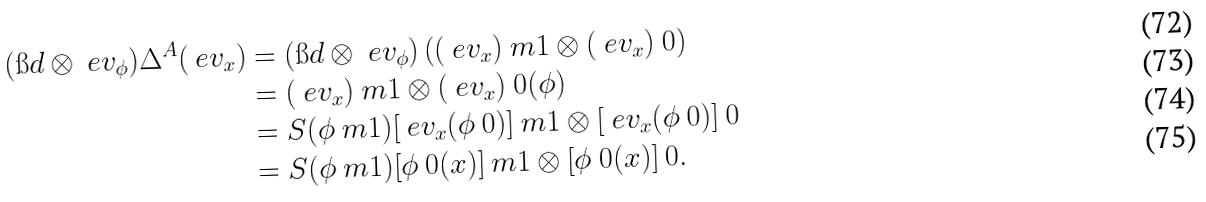<formula> <loc_0><loc_0><loc_500><loc_500>( \i d \otimes \ e v _ { \phi } ) \Delta ^ { A } ( \ e v _ { x } ) & = ( \i d \otimes \ e v _ { \phi } ) \left ( ( \ e v _ { x } ) \ m 1 \otimes ( \ e v _ { x } ) \ 0 \right ) \\ & = ( \ e v _ { x } ) \ m 1 \otimes ( \ e v _ { x } ) \ 0 ( \phi ) \\ & = S ( \phi \ m 1 ) [ \ e v _ { x } ( \phi \ 0 ) ] \ m 1 \otimes [ \ e v _ { x } ( \phi \ 0 ) ] \ 0 \\ & = S ( \phi \ m 1 ) [ \phi \ 0 ( x ) ] \ m 1 \otimes [ \phi \ 0 ( x ) ] \ 0 .</formula> 